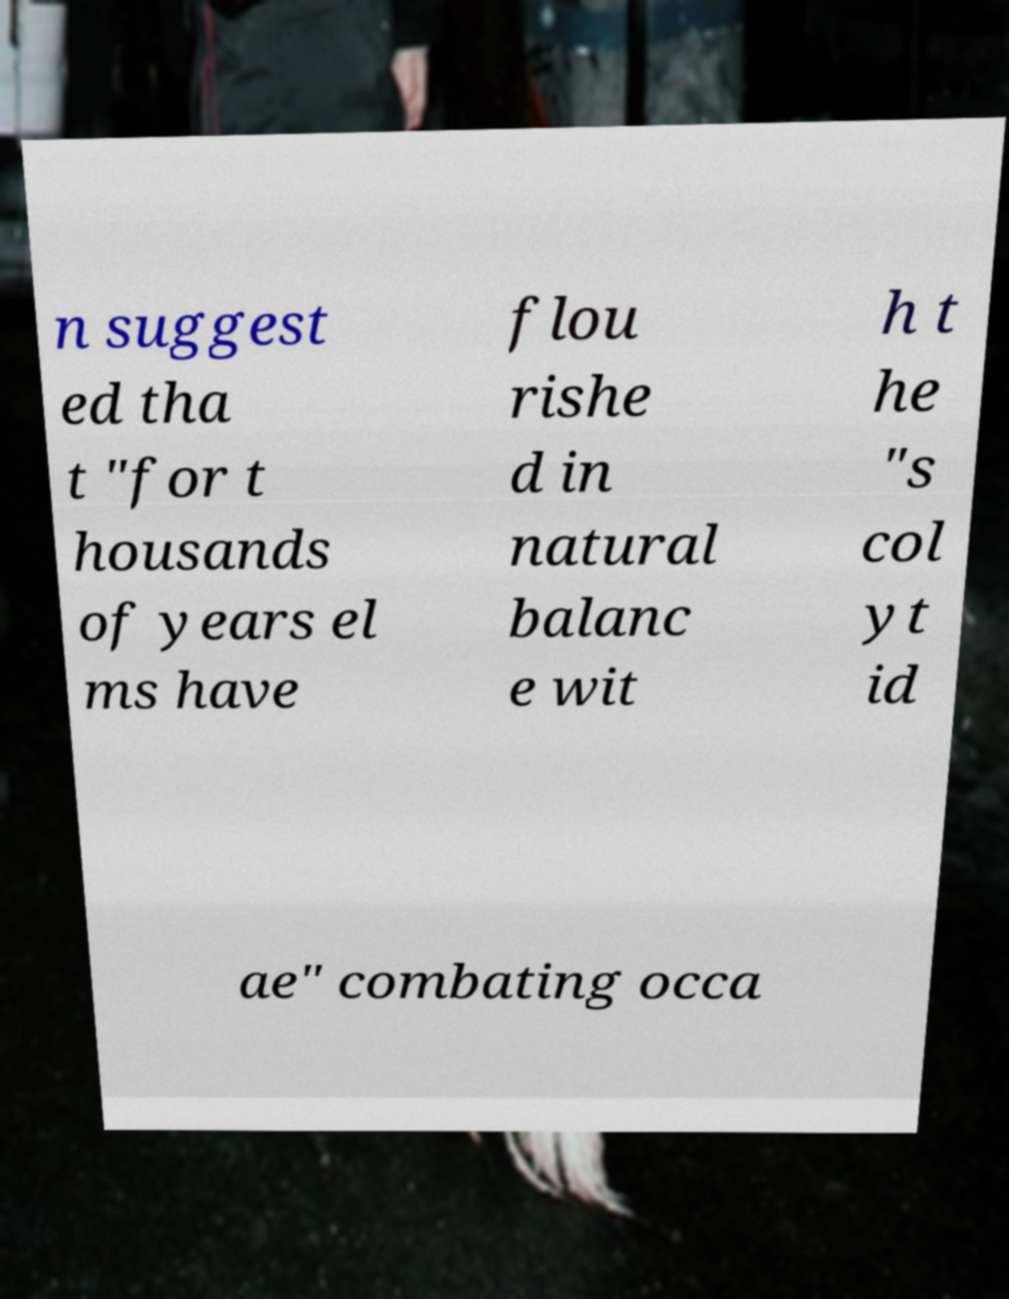Can you read and provide the text displayed in the image?This photo seems to have some interesting text. Can you extract and type it out for me? n suggest ed tha t "for t housands of years el ms have flou rishe d in natural balanc e wit h t he "s col yt id ae" combating occa 